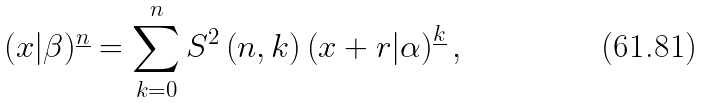Convert formula to latex. <formula><loc_0><loc_0><loc_500><loc_500>( x | \beta ) ^ { \underline { n } } = \sum _ { k = 0 } ^ { n } S ^ { 2 } \left ( n , k \right ) \left ( x + r | \alpha \right ) ^ { \underline { k } } ,</formula> 